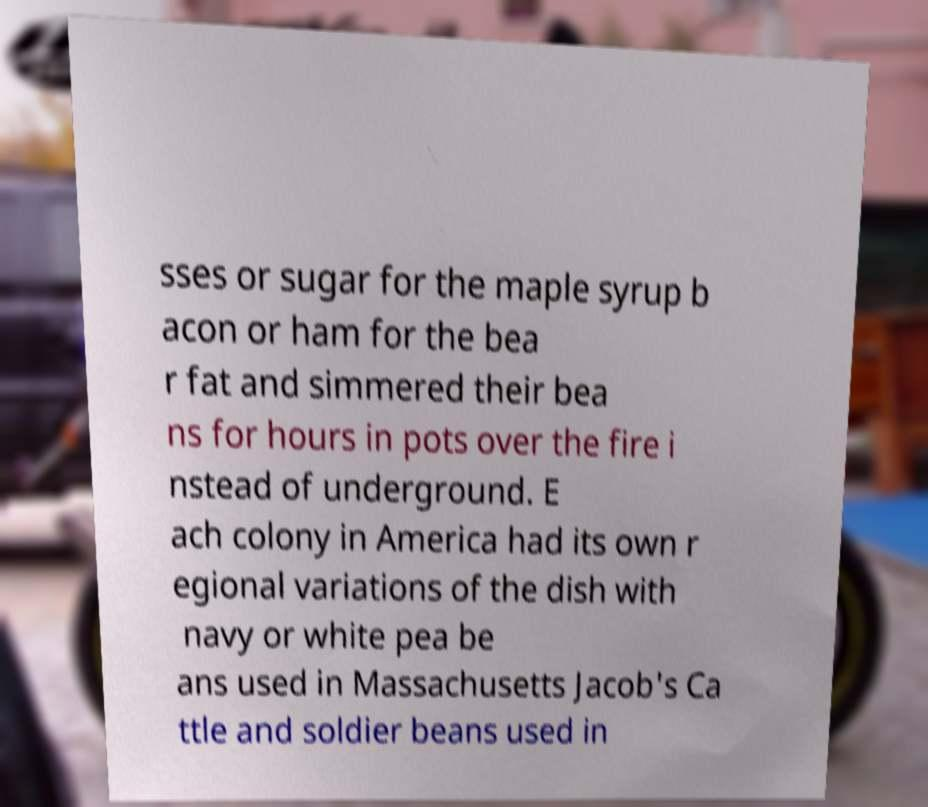Could you extract and type out the text from this image? sses or sugar for the maple syrup b acon or ham for the bea r fat and simmered their bea ns for hours in pots over the fire i nstead of underground. E ach colony in America had its own r egional variations of the dish with navy or white pea be ans used in Massachusetts Jacob's Ca ttle and soldier beans used in 